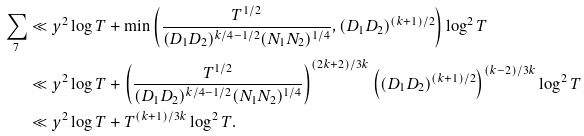Convert formula to latex. <formula><loc_0><loc_0><loc_500><loc_500>\sum _ { 7 } & \ll y ^ { 2 } \log T + \min \left ( \frac { T ^ { 1 / 2 } } { ( D _ { 1 } D _ { 2 } ) ^ { k / 4 - 1 / 2 } ( N _ { 1 } N _ { 2 } ) ^ { 1 / 4 } } , ( D _ { 1 } D _ { 2 } ) ^ { ( k + 1 ) / 2 } \right ) \log ^ { 2 } T \\ & \ll y ^ { 2 } \log T + \left ( \frac { T ^ { 1 / 2 } } { ( D _ { 1 } D _ { 2 } ) ^ { k / 4 - 1 / 2 } ( N _ { 1 } N _ { 2 } ) ^ { 1 / 4 } } \right ) ^ { ( 2 k + 2 ) / 3 k } \left ( ( D _ { 1 } D _ { 2 } ) ^ { ( k + 1 ) / 2 } \right ) ^ { ( k - 2 ) / 3 k } \log ^ { 2 } T \\ & \ll y ^ { 2 } \log T + T ^ { ( k + 1 ) / 3 k } \log ^ { 2 } T .</formula> 